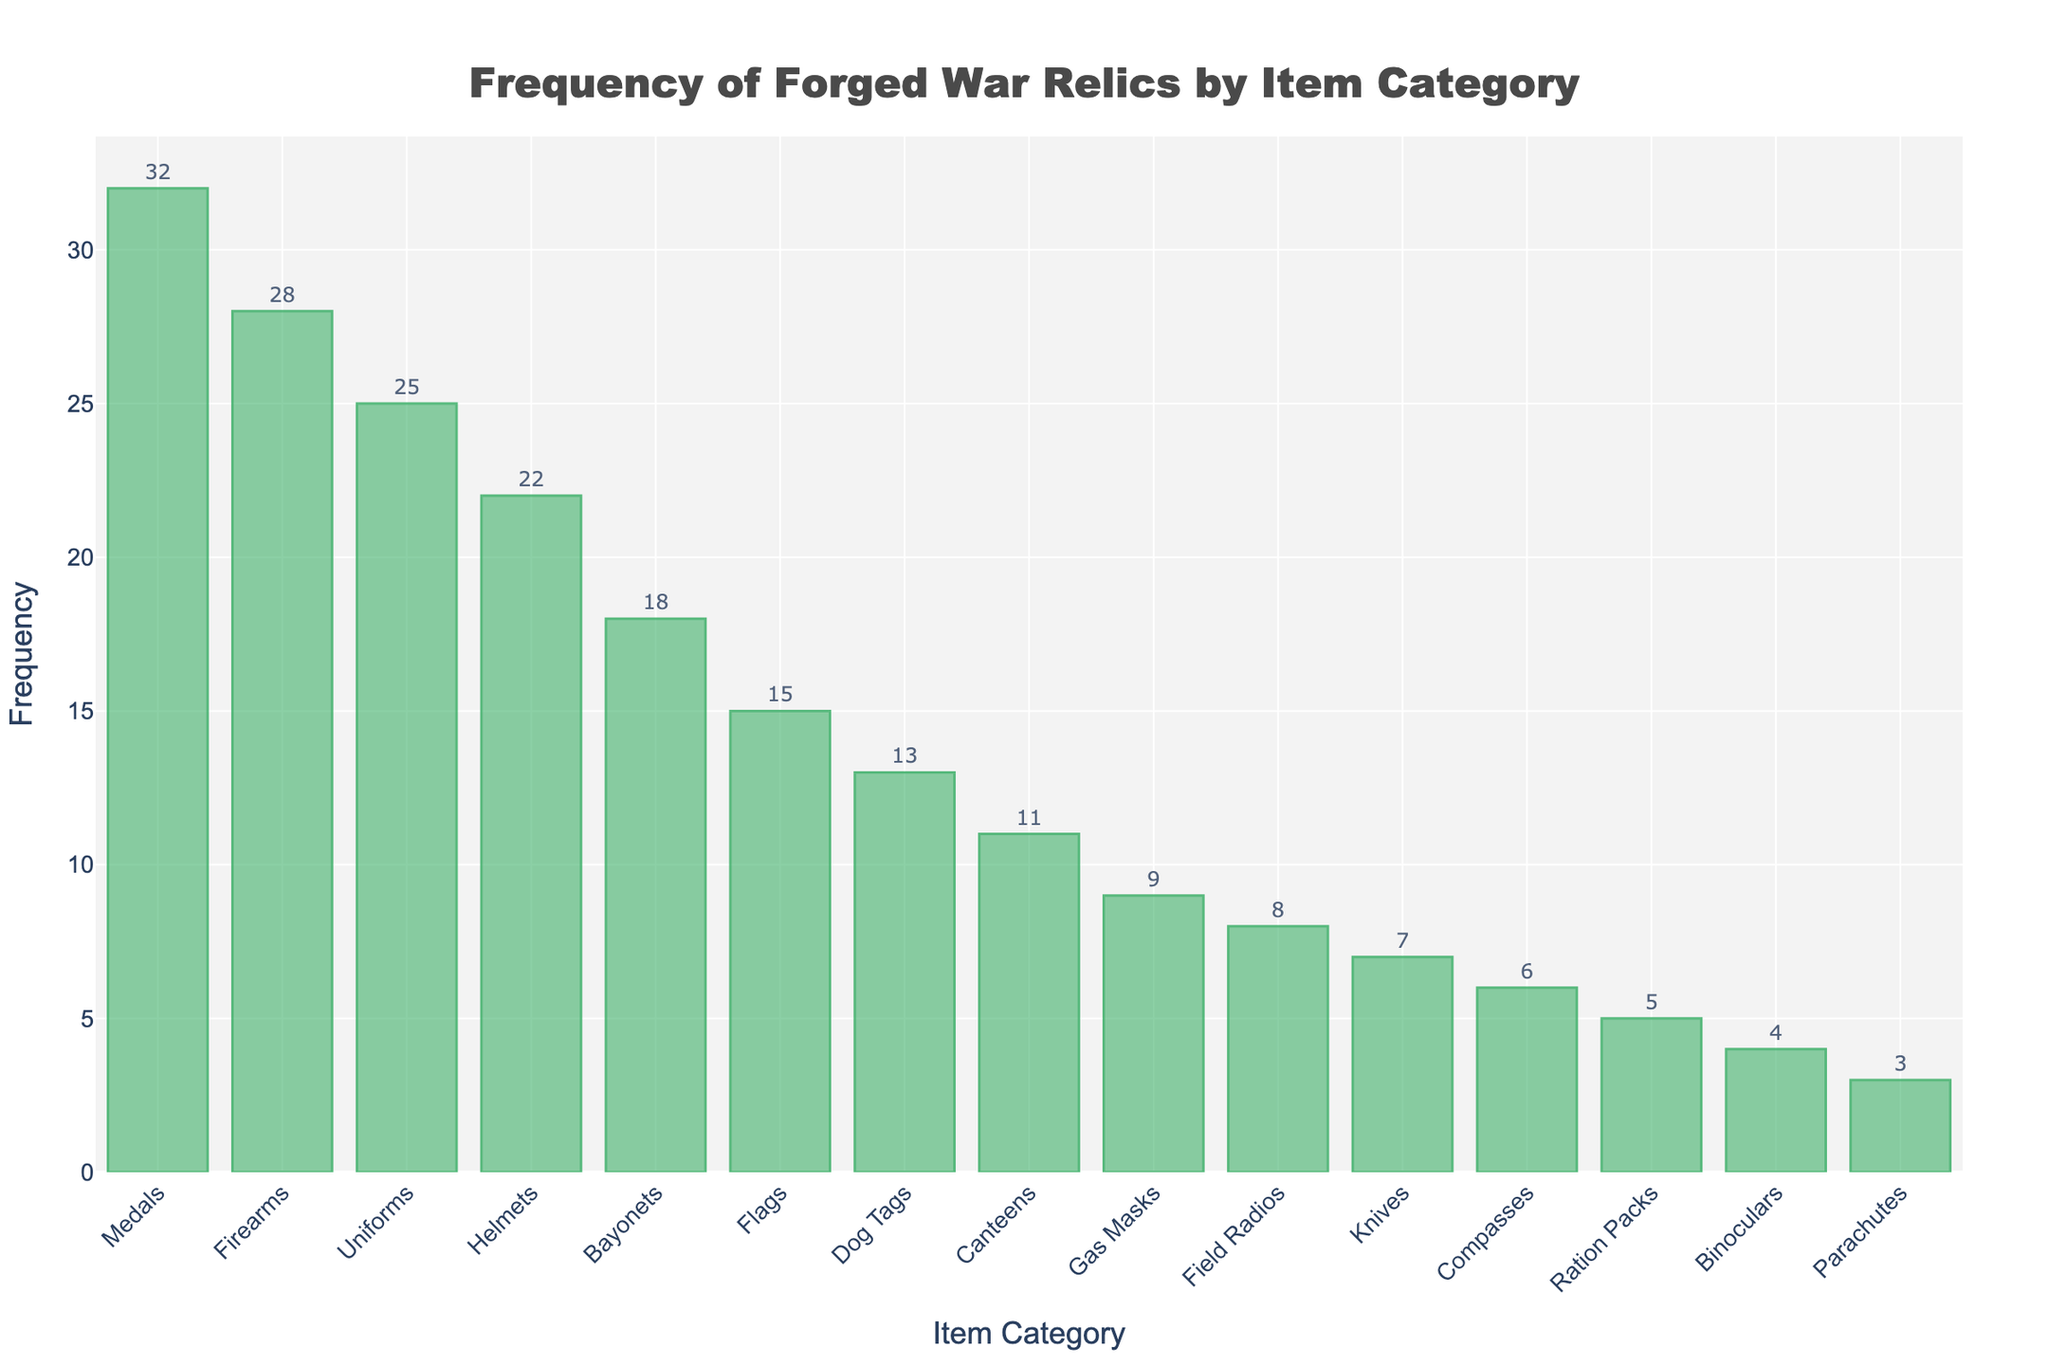What's the most frequently forged war relic category? The height of the bars represents the frequency of forgeries. The tallest bar corresponds to medals, indicating that they are the most frequently forged category.
Answer: Medals Which item category has the lowest frequency of forgeries? The shortest bar represents the lowest frequency of forgeries. The bar corresponding to parachutes is the shortest.
Answer: Parachutes What is the total frequency of forged items in the top three categories? The top three categories based on bar height are medals, firearms, and uniforms. Adding their frequencies: 32 (medals) + 28 (firearms) + 25 (uniforms) = 85.
Answer: 85 Are there more forgeries of firearms or bayonets? Comparing the heights of the bars for firearms and bayonets, the bar for firearms is taller. Thus, there are more forgeries of firearms.
Answer: Firearms What's the difference in the frequency of forgeries between helmets and gas masks? The frequency for helmets is 22, and for gas masks, it is 9. Subtracting these: 22 - 9 = 13.
Answer: 13 What is the average frequency of forgeries for medals, flags, and knives? The frequencies are 32 (medals), 15 (flags), and 7 (knives). Summing them up: 32 + 15 + 7 = 54. Dividing by the number of items, 54 / 3 = 18.
Answer: 18 Which has a higher frequency of forgeries: canteens or field radios? By comparing the heights of the bars, the bar for canteens is taller than the one for field radios.
Answer: Canteens What is the total frequency of forged items in categories with more than 20 forgeries? The categories with more than 20 forgeries are medals (32), firearms (28), uniforms (25), and helmets (22). Summing these frequencies: 32 + 28 + 25 + 22 = 107.
Answer: 107 Is the frequency of forged dog tags higher than the frequency of forged compasses? The bar for dog tags (13) is taller than the bar for compasses (6). Therefore, the frequency of forged dog tags is higher.
Answer: Yes Which categories have a frequency of forgeries greater than 10 but less than 20? By looking at bars in this range, the categories are bayonets (18), flags (15), and dog tags (13).
Answer: Bayonets, Flags, Dog Tags 